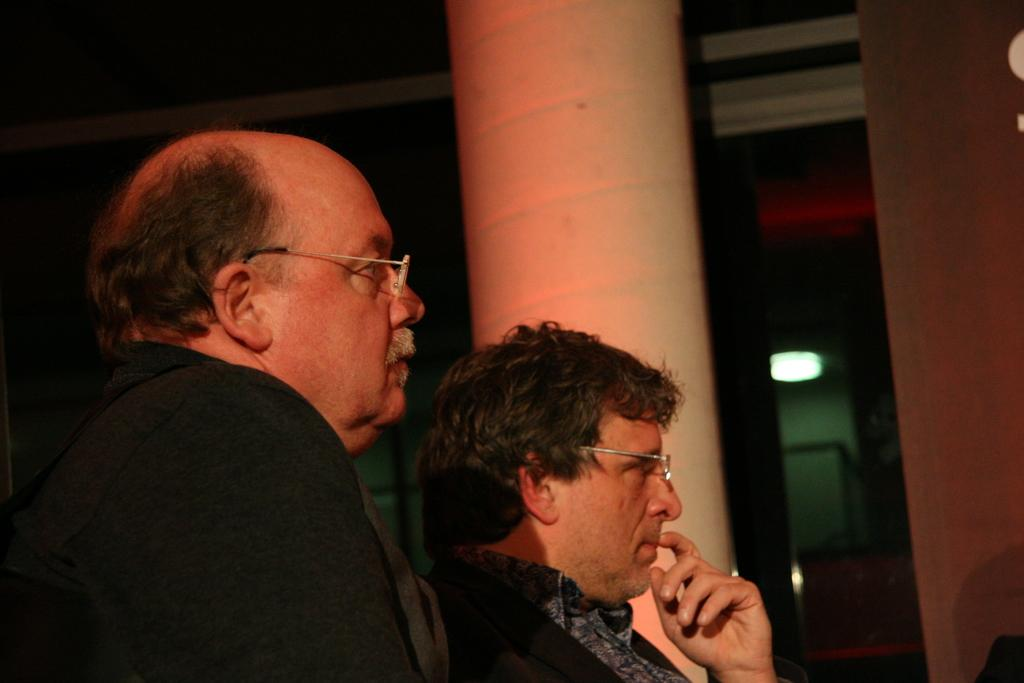How many people are in the image? There are two people in the image. What can be observed about one of the people's appearance? One person is wearing spectacles. What is the other person wearing? The other person is wearing a black coat. What can be seen in the background of the image? There is a pole and lights in the background of the image. What type of drum can be heard playing in the background of the image? There is no drum or sound present in the image; it is a still photograph. 